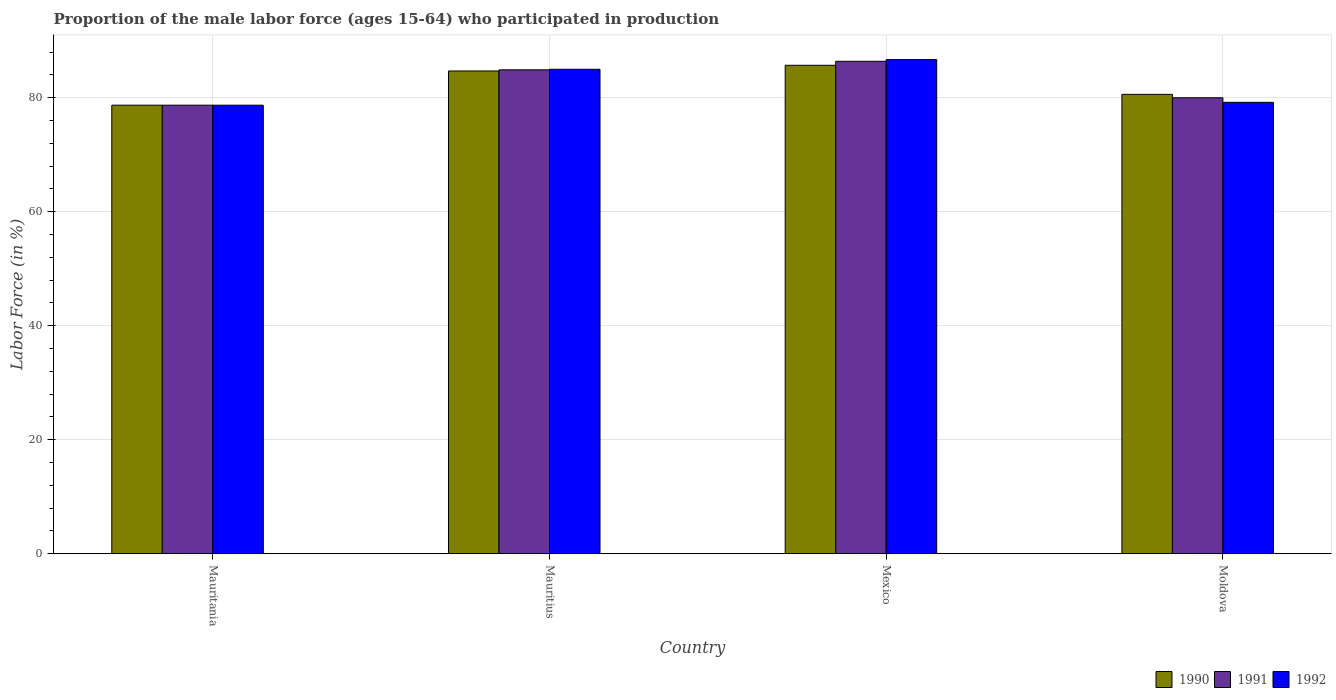How many different coloured bars are there?
Provide a succinct answer. 3. Are the number of bars per tick equal to the number of legend labels?
Make the answer very short. Yes. What is the label of the 4th group of bars from the left?
Your response must be concise. Moldova. In how many cases, is the number of bars for a given country not equal to the number of legend labels?
Provide a short and direct response. 0. What is the proportion of the male labor force who participated in production in 1992 in Moldova?
Ensure brevity in your answer.  79.2. Across all countries, what is the maximum proportion of the male labor force who participated in production in 1990?
Ensure brevity in your answer.  85.7. Across all countries, what is the minimum proportion of the male labor force who participated in production in 1991?
Keep it short and to the point. 78.7. In which country was the proportion of the male labor force who participated in production in 1990 maximum?
Your response must be concise. Mexico. In which country was the proportion of the male labor force who participated in production in 1990 minimum?
Your answer should be very brief. Mauritania. What is the total proportion of the male labor force who participated in production in 1991 in the graph?
Offer a terse response. 330. What is the difference between the proportion of the male labor force who participated in production in 1991 in Mauritania and that in Mexico?
Your answer should be very brief. -7.7. What is the average proportion of the male labor force who participated in production in 1992 per country?
Make the answer very short. 82.4. What is the difference between the proportion of the male labor force who participated in production of/in 1990 and proportion of the male labor force who participated in production of/in 1992 in Mauritius?
Keep it short and to the point. -0.3. What is the ratio of the proportion of the male labor force who participated in production in 1990 in Mauritius to that in Mexico?
Keep it short and to the point. 0.99. Is the difference between the proportion of the male labor force who participated in production in 1990 in Mauritius and Mexico greater than the difference between the proportion of the male labor force who participated in production in 1992 in Mauritius and Mexico?
Give a very brief answer. Yes. What is the difference between the highest and the second highest proportion of the male labor force who participated in production in 1992?
Your answer should be compact. -1.7. In how many countries, is the proportion of the male labor force who participated in production in 1992 greater than the average proportion of the male labor force who participated in production in 1992 taken over all countries?
Offer a very short reply. 2. Is the sum of the proportion of the male labor force who participated in production in 1992 in Mexico and Moldova greater than the maximum proportion of the male labor force who participated in production in 1991 across all countries?
Give a very brief answer. Yes. What does the 2nd bar from the left in Mexico represents?
Offer a very short reply. 1991. How many bars are there?
Offer a very short reply. 12. What is the difference between two consecutive major ticks on the Y-axis?
Provide a succinct answer. 20. Does the graph contain any zero values?
Offer a very short reply. No. What is the title of the graph?
Offer a terse response. Proportion of the male labor force (ages 15-64) who participated in production. Does "1992" appear as one of the legend labels in the graph?
Provide a succinct answer. Yes. What is the label or title of the X-axis?
Keep it short and to the point. Country. What is the Labor Force (in %) in 1990 in Mauritania?
Provide a short and direct response. 78.7. What is the Labor Force (in %) in 1991 in Mauritania?
Your answer should be compact. 78.7. What is the Labor Force (in %) in 1992 in Mauritania?
Ensure brevity in your answer.  78.7. What is the Labor Force (in %) in 1990 in Mauritius?
Ensure brevity in your answer.  84.7. What is the Labor Force (in %) in 1991 in Mauritius?
Offer a terse response. 84.9. What is the Labor Force (in %) of 1992 in Mauritius?
Offer a very short reply. 85. What is the Labor Force (in %) in 1990 in Mexico?
Keep it short and to the point. 85.7. What is the Labor Force (in %) in 1991 in Mexico?
Give a very brief answer. 86.4. What is the Labor Force (in %) in 1992 in Mexico?
Offer a very short reply. 86.7. What is the Labor Force (in %) of 1990 in Moldova?
Your answer should be compact. 80.6. What is the Labor Force (in %) in 1991 in Moldova?
Offer a very short reply. 80. What is the Labor Force (in %) of 1992 in Moldova?
Offer a very short reply. 79.2. Across all countries, what is the maximum Labor Force (in %) of 1990?
Give a very brief answer. 85.7. Across all countries, what is the maximum Labor Force (in %) of 1991?
Your answer should be compact. 86.4. Across all countries, what is the maximum Labor Force (in %) in 1992?
Ensure brevity in your answer.  86.7. Across all countries, what is the minimum Labor Force (in %) of 1990?
Provide a short and direct response. 78.7. Across all countries, what is the minimum Labor Force (in %) of 1991?
Offer a terse response. 78.7. Across all countries, what is the minimum Labor Force (in %) of 1992?
Ensure brevity in your answer.  78.7. What is the total Labor Force (in %) of 1990 in the graph?
Ensure brevity in your answer.  329.7. What is the total Labor Force (in %) in 1991 in the graph?
Make the answer very short. 330. What is the total Labor Force (in %) of 1992 in the graph?
Offer a very short reply. 329.6. What is the difference between the Labor Force (in %) in 1992 in Mauritania and that in Mauritius?
Offer a terse response. -6.3. What is the difference between the Labor Force (in %) in 1990 in Mauritania and that in Mexico?
Give a very brief answer. -7. What is the difference between the Labor Force (in %) in 1992 in Mauritania and that in Mexico?
Provide a short and direct response. -8. What is the difference between the Labor Force (in %) of 1991 in Mauritania and that in Moldova?
Give a very brief answer. -1.3. What is the difference between the Labor Force (in %) of 1992 in Mauritius and that in Mexico?
Provide a short and direct response. -1.7. What is the difference between the Labor Force (in %) of 1992 in Mauritius and that in Moldova?
Provide a short and direct response. 5.8. What is the difference between the Labor Force (in %) of 1990 in Mexico and that in Moldova?
Your answer should be very brief. 5.1. What is the difference between the Labor Force (in %) of 1991 in Mexico and that in Moldova?
Offer a terse response. 6.4. What is the difference between the Labor Force (in %) in 1990 in Mauritania and the Labor Force (in %) in 1992 in Mauritius?
Your response must be concise. -6.3. What is the difference between the Labor Force (in %) of 1990 in Mauritania and the Labor Force (in %) of 1991 in Mexico?
Your answer should be very brief. -7.7. What is the difference between the Labor Force (in %) of 1990 in Mauritania and the Labor Force (in %) of 1992 in Mexico?
Provide a short and direct response. -8. What is the difference between the Labor Force (in %) of 1991 in Mauritania and the Labor Force (in %) of 1992 in Mexico?
Provide a short and direct response. -8. What is the difference between the Labor Force (in %) of 1990 in Mauritania and the Labor Force (in %) of 1992 in Moldova?
Provide a succinct answer. -0.5. What is the difference between the Labor Force (in %) of 1991 in Mauritania and the Labor Force (in %) of 1992 in Moldova?
Your answer should be compact. -0.5. What is the difference between the Labor Force (in %) in 1990 in Mauritius and the Labor Force (in %) in 1991 in Mexico?
Provide a short and direct response. -1.7. What is the difference between the Labor Force (in %) of 1990 in Mauritius and the Labor Force (in %) of 1992 in Mexico?
Ensure brevity in your answer.  -2. What is the difference between the Labor Force (in %) in 1991 in Mauritius and the Labor Force (in %) in 1992 in Moldova?
Your response must be concise. 5.7. What is the difference between the Labor Force (in %) of 1990 in Mexico and the Labor Force (in %) of 1992 in Moldova?
Give a very brief answer. 6.5. What is the average Labor Force (in %) of 1990 per country?
Ensure brevity in your answer.  82.42. What is the average Labor Force (in %) in 1991 per country?
Your response must be concise. 82.5. What is the average Labor Force (in %) of 1992 per country?
Your answer should be very brief. 82.4. What is the difference between the Labor Force (in %) in 1990 and Labor Force (in %) in 1992 in Mauritania?
Ensure brevity in your answer.  0. What is the difference between the Labor Force (in %) in 1990 and Labor Force (in %) in 1991 in Mauritius?
Provide a short and direct response. -0.2. What is the difference between the Labor Force (in %) in 1990 and Labor Force (in %) in 1992 in Mauritius?
Give a very brief answer. -0.3. What is the difference between the Labor Force (in %) in 1991 and Labor Force (in %) in 1992 in Mexico?
Your answer should be compact. -0.3. What is the difference between the Labor Force (in %) in 1991 and Labor Force (in %) in 1992 in Moldova?
Provide a succinct answer. 0.8. What is the ratio of the Labor Force (in %) of 1990 in Mauritania to that in Mauritius?
Your answer should be compact. 0.93. What is the ratio of the Labor Force (in %) in 1991 in Mauritania to that in Mauritius?
Provide a short and direct response. 0.93. What is the ratio of the Labor Force (in %) of 1992 in Mauritania to that in Mauritius?
Provide a succinct answer. 0.93. What is the ratio of the Labor Force (in %) in 1990 in Mauritania to that in Mexico?
Offer a very short reply. 0.92. What is the ratio of the Labor Force (in %) of 1991 in Mauritania to that in Mexico?
Keep it short and to the point. 0.91. What is the ratio of the Labor Force (in %) of 1992 in Mauritania to that in Mexico?
Your answer should be compact. 0.91. What is the ratio of the Labor Force (in %) in 1990 in Mauritania to that in Moldova?
Your response must be concise. 0.98. What is the ratio of the Labor Force (in %) of 1991 in Mauritania to that in Moldova?
Provide a succinct answer. 0.98. What is the ratio of the Labor Force (in %) of 1992 in Mauritania to that in Moldova?
Provide a succinct answer. 0.99. What is the ratio of the Labor Force (in %) of 1990 in Mauritius to that in Mexico?
Your answer should be compact. 0.99. What is the ratio of the Labor Force (in %) of 1991 in Mauritius to that in Mexico?
Give a very brief answer. 0.98. What is the ratio of the Labor Force (in %) of 1992 in Mauritius to that in Mexico?
Provide a short and direct response. 0.98. What is the ratio of the Labor Force (in %) in 1990 in Mauritius to that in Moldova?
Offer a very short reply. 1.05. What is the ratio of the Labor Force (in %) of 1991 in Mauritius to that in Moldova?
Ensure brevity in your answer.  1.06. What is the ratio of the Labor Force (in %) in 1992 in Mauritius to that in Moldova?
Provide a succinct answer. 1.07. What is the ratio of the Labor Force (in %) in 1990 in Mexico to that in Moldova?
Your answer should be compact. 1.06. What is the ratio of the Labor Force (in %) of 1991 in Mexico to that in Moldova?
Give a very brief answer. 1.08. What is the ratio of the Labor Force (in %) in 1992 in Mexico to that in Moldova?
Keep it short and to the point. 1.09. What is the difference between the highest and the second highest Labor Force (in %) of 1991?
Keep it short and to the point. 1.5. 